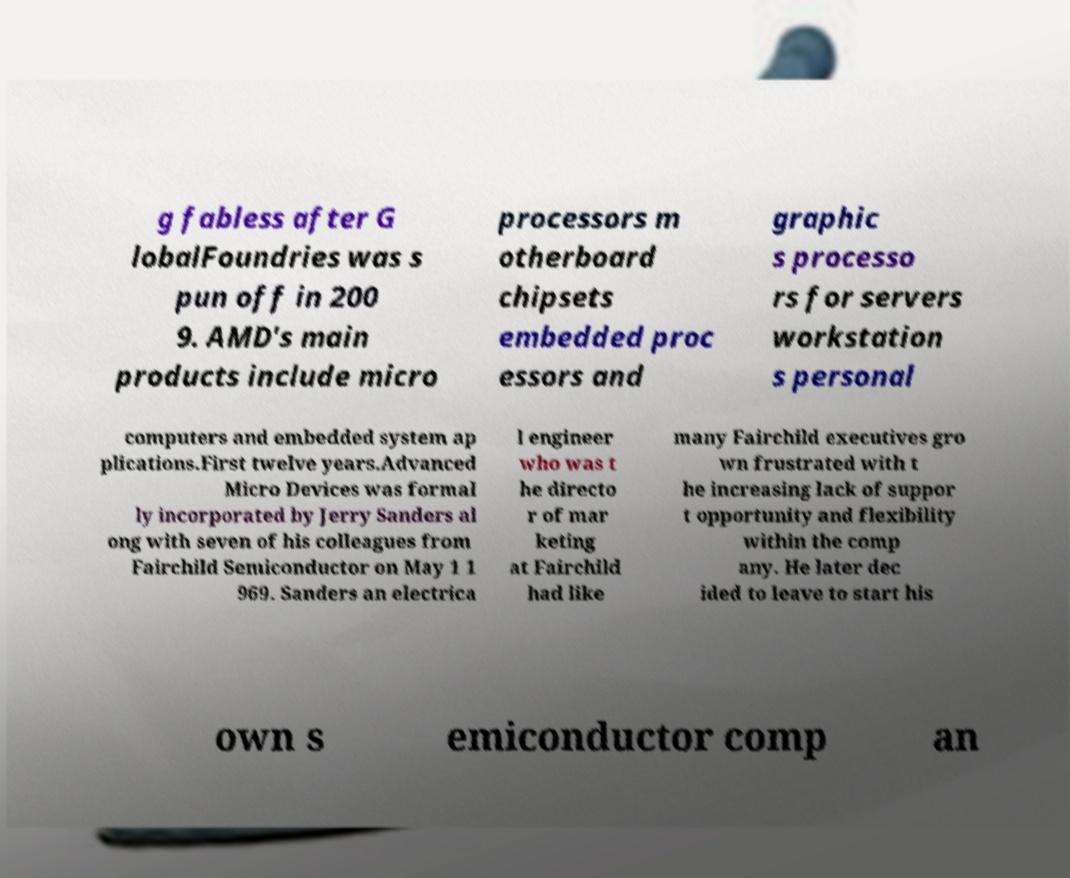For documentation purposes, I need the text within this image transcribed. Could you provide that? g fabless after G lobalFoundries was s pun off in 200 9. AMD's main products include micro processors m otherboard chipsets embedded proc essors and graphic s processo rs for servers workstation s personal computers and embedded system ap plications.First twelve years.Advanced Micro Devices was formal ly incorporated by Jerry Sanders al ong with seven of his colleagues from Fairchild Semiconductor on May 1 1 969. Sanders an electrica l engineer who was t he directo r of mar keting at Fairchild had like many Fairchild executives gro wn frustrated with t he increasing lack of suppor t opportunity and flexibility within the comp any. He later dec ided to leave to start his own s emiconductor comp an 